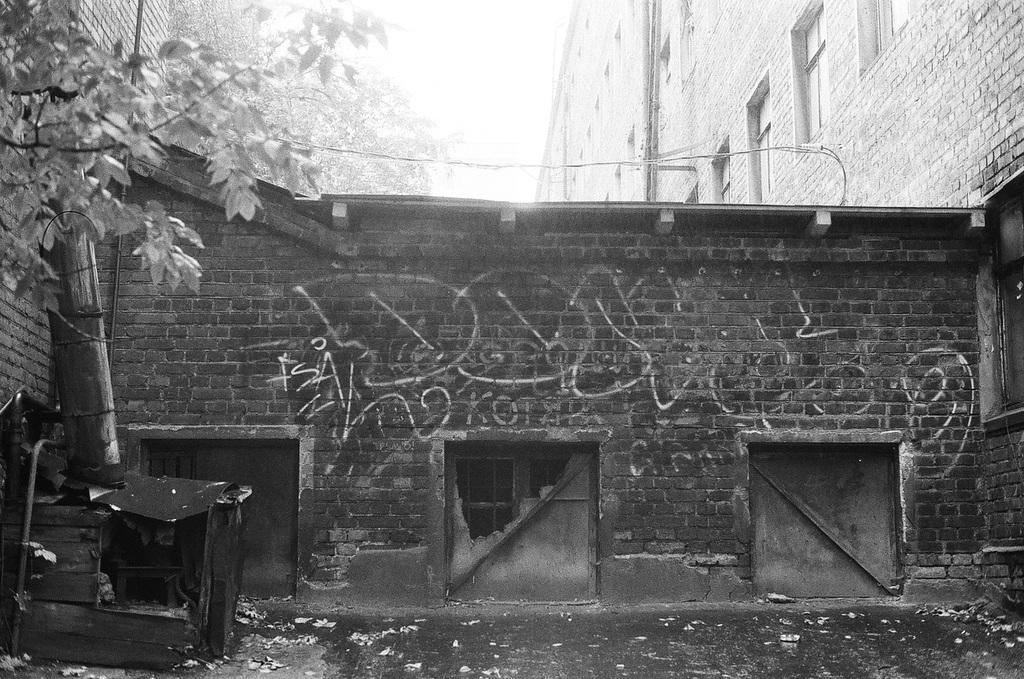What is located on the left side of the image? There is a tree on the left side of the image. What type of structures can be seen in the image? There are buildings with windows in the image. Are there any other trees visible in the image? Yes, there is a tree at the back of the image. What is the color scheme of the image? The image is black and white. What sign can be seen on the tree at the back of the image? There is no sign present on the tree at the back of the image, as the image is black and white and does not show any signs. How many divisions are there in the tree at the back of the image? The image is black and white and does not show any divisions in the tree; it only shows the tree's outline. 